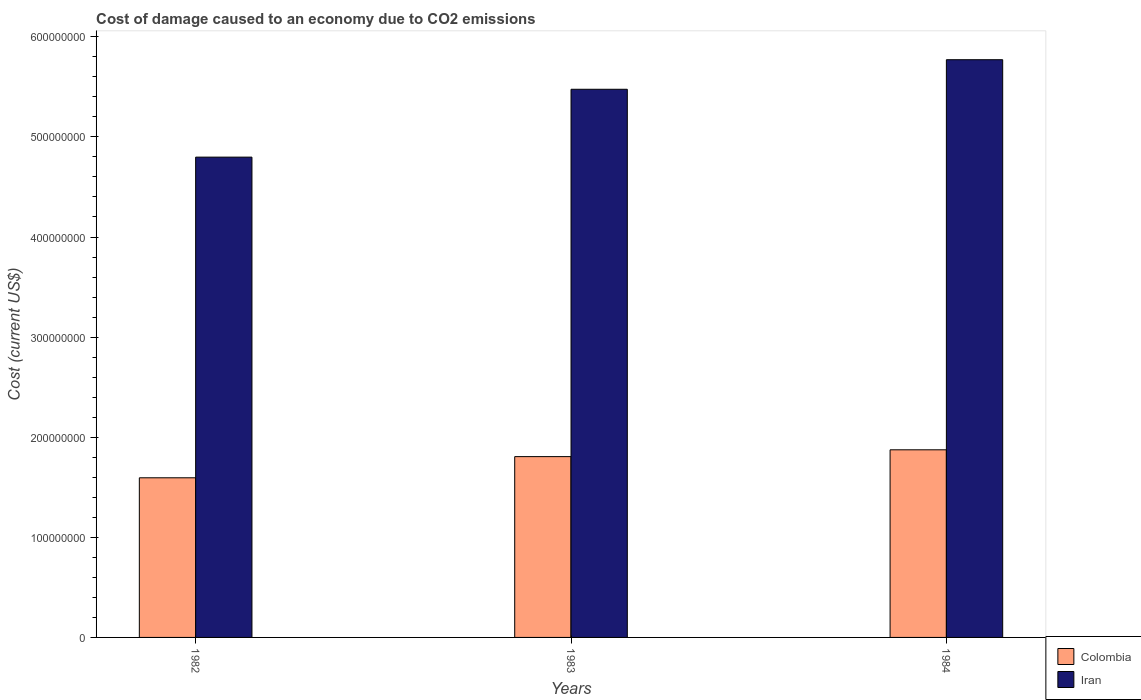How many groups of bars are there?
Provide a succinct answer. 3. Are the number of bars per tick equal to the number of legend labels?
Provide a succinct answer. Yes. How many bars are there on the 3rd tick from the left?
Your answer should be very brief. 2. What is the cost of damage caused due to CO2 emissisons in Colombia in 1983?
Make the answer very short. 1.81e+08. Across all years, what is the maximum cost of damage caused due to CO2 emissisons in Iran?
Ensure brevity in your answer.  5.77e+08. Across all years, what is the minimum cost of damage caused due to CO2 emissisons in Colombia?
Provide a succinct answer. 1.59e+08. In which year was the cost of damage caused due to CO2 emissisons in Colombia maximum?
Provide a short and direct response. 1984. What is the total cost of damage caused due to CO2 emissisons in Iran in the graph?
Offer a terse response. 1.60e+09. What is the difference between the cost of damage caused due to CO2 emissisons in Iran in 1982 and that in 1984?
Your answer should be compact. -9.73e+07. What is the difference between the cost of damage caused due to CO2 emissisons in Iran in 1982 and the cost of damage caused due to CO2 emissisons in Colombia in 1983?
Give a very brief answer. 2.99e+08. What is the average cost of damage caused due to CO2 emissisons in Iran per year?
Keep it short and to the point. 5.35e+08. In the year 1983, what is the difference between the cost of damage caused due to CO2 emissisons in Colombia and cost of damage caused due to CO2 emissisons in Iran?
Your answer should be compact. -3.67e+08. What is the ratio of the cost of damage caused due to CO2 emissisons in Iran in 1982 to that in 1983?
Your answer should be very brief. 0.88. Is the cost of damage caused due to CO2 emissisons in Iran in 1982 less than that in 1983?
Your response must be concise. Yes. What is the difference between the highest and the second highest cost of damage caused due to CO2 emissisons in Colombia?
Keep it short and to the point. 6.81e+06. What is the difference between the highest and the lowest cost of damage caused due to CO2 emissisons in Colombia?
Your answer should be very brief. 2.80e+07. In how many years, is the cost of damage caused due to CO2 emissisons in Colombia greater than the average cost of damage caused due to CO2 emissisons in Colombia taken over all years?
Your response must be concise. 2. Is the sum of the cost of damage caused due to CO2 emissisons in Iran in 1982 and 1983 greater than the maximum cost of damage caused due to CO2 emissisons in Colombia across all years?
Keep it short and to the point. Yes. What does the 2nd bar from the left in 1984 represents?
Keep it short and to the point. Iran. Are all the bars in the graph horizontal?
Your answer should be compact. No. Are the values on the major ticks of Y-axis written in scientific E-notation?
Your response must be concise. No. Does the graph contain grids?
Offer a terse response. No. Where does the legend appear in the graph?
Ensure brevity in your answer.  Bottom right. How many legend labels are there?
Your response must be concise. 2. How are the legend labels stacked?
Provide a short and direct response. Vertical. What is the title of the graph?
Keep it short and to the point. Cost of damage caused to an economy due to CO2 emissions. What is the label or title of the X-axis?
Ensure brevity in your answer.  Years. What is the label or title of the Y-axis?
Ensure brevity in your answer.  Cost (current US$). What is the Cost (current US$) of Colombia in 1982?
Your answer should be compact. 1.59e+08. What is the Cost (current US$) in Iran in 1982?
Your answer should be compact. 4.80e+08. What is the Cost (current US$) of Colombia in 1983?
Provide a succinct answer. 1.81e+08. What is the Cost (current US$) in Iran in 1983?
Your answer should be very brief. 5.48e+08. What is the Cost (current US$) in Colombia in 1984?
Your response must be concise. 1.87e+08. What is the Cost (current US$) in Iran in 1984?
Provide a succinct answer. 5.77e+08. Across all years, what is the maximum Cost (current US$) of Colombia?
Your answer should be very brief. 1.87e+08. Across all years, what is the maximum Cost (current US$) of Iran?
Give a very brief answer. 5.77e+08. Across all years, what is the minimum Cost (current US$) in Colombia?
Give a very brief answer. 1.59e+08. Across all years, what is the minimum Cost (current US$) in Iran?
Your response must be concise. 4.80e+08. What is the total Cost (current US$) of Colombia in the graph?
Your response must be concise. 5.28e+08. What is the total Cost (current US$) of Iran in the graph?
Your answer should be compact. 1.60e+09. What is the difference between the Cost (current US$) of Colombia in 1982 and that in 1983?
Keep it short and to the point. -2.12e+07. What is the difference between the Cost (current US$) in Iran in 1982 and that in 1983?
Your answer should be compact. -6.78e+07. What is the difference between the Cost (current US$) in Colombia in 1982 and that in 1984?
Offer a terse response. -2.80e+07. What is the difference between the Cost (current US$) in Iran in 1982 and that in 1984?
Your answer should be compact. -9.73e+07. What is the difference between the Cost (current US$) in Colombia in 1983 and that in 1984?
Provide a succinct answer. -6.81e+06. What is the difference between the Cost (current US$) of Iran in 1983 and that in 1984?
Provide a succinct answer. -2.95e+07. What is the difference between the Cost (current US$) in Colombia in 1982 and the Cost (current US$) in Iran in 1983?
Your answer should be very brief. -3.88e+08. What is the difference between the Cost (current US$) of Colombia in 1982 and the Cost (current US$) of Iran in 1984?
Provide a short and direct response. -4.18e+08. What is the difference between the Cost (current US$) in Colombia in 1983 and the Cost (current US$) in Iran in 1984?
Your answer should be compact. -3.96e+08. What is the average Cost (current US$) in Colombia per year?
Make the answer very short. 1.76e+08. What is the average Cost (current US$) of Iran per year?
Your response must be concise. 5.35e+08. In the year 1982, what is the difference between the Cost (current US$) in Colombia and Cost (current US$) in Iran?
Give a very brief answer. -3.20e+08. In the year 1983, what is the difference between the Cost (current US$) in Colombia and Cost (current US$) in Iran?
Your answer should be compact. -3.67e+08. In the year 1984, what is the difference between the Cost (current US$) of Colombia and Cost (current US$) of Iran?
Make the answer very short. -3.90e+08. What is the ratio of the Cost (current US$) of Colombia in 1982 to that in 1983?
Your answer should be very brief. 0.88. What is the ratio of the Cost (current US$) of Iran in 1982 to that in 1983?
Your answer should be compact. 0.88. What is the ratio of the Cost (current US$) in Colombia in 1982 to that in 1984?
Your answer should be very brief. 0.85. What is the ratio of the Cost (current US$) in Iran in 1982 to that in 1984?
Give a very brief answer. 0.83. What is the ratio of the Cost (current US$) of Colombia in 1983 to that in 1984?
Your answer should be very brief. 0.96. What is the ratio of the Cost (current US$) in Iran in 1983 to that in 1984?
Your answer should be very brief. 0.95. What is the difference between the highest and the second highest Cost (current US$) of Colombia?
Give a very brief answer. 6.81e+06. What is the difference between the highest and the second highest Cost (current US$) in Iran?
Your response must be concise. 2.95e+07. What is the difference between the highest and the lowest Cost (current US$) in Colombia?
Your response must be concise. 2.80e+07. What is the difference between the highest and the lowest Cost (current US$) in Iran?
Your response must be concise. 9.73e+07. 